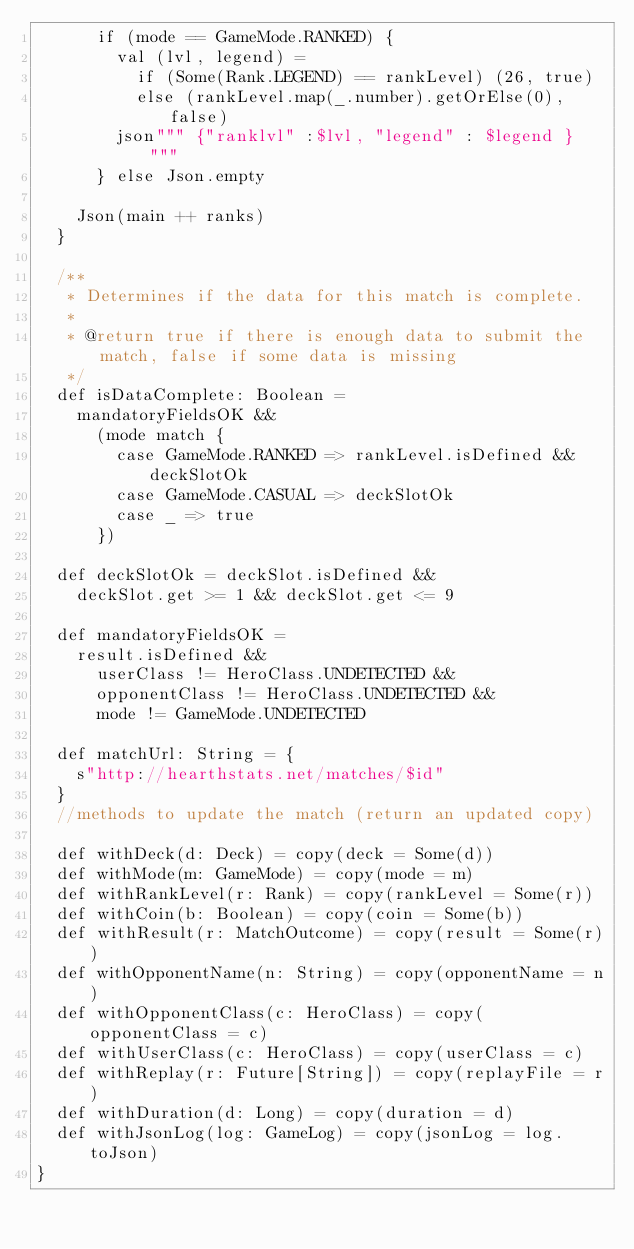<code> <loc_0><loc_0><loc_500><loc_500><_Scala_>      if (mode == GameMode.RANKED) {
        val (lvl, legend) =
          if (Some(Rank.LEGEND) == rankLevel) (26, true)
          else (rankLevel.map(_.number).getOrElse(0), false)
        json""" {"ranklvl" :$lvl, "legend" : $legend } """
      } else Json.empty

    Json(main ++ ranks)
  }

  /**
   * Determines if the data for this match is complete.
   *
   * @return true if there is enough data to submit the match, false if some data is missing
   */
  def isDataComplete: Boolean =
    mandatoryFieldsOK &&
      (mode match {
        case GameMode.RANKED => rankLevel.isDefined && deckSlotOk
        case GameMode.CASUAL => deckSlotOk
        case _ => true
      })

  def deckSlotOk = deckSlot.isDefined &&
    deckSlot.get >= 1 && deckSlot.get <= 9

  def mandatoryFieldsOK =
    result.isDefined &&
      userClass != HeroClass.UNDETECTED &&
      opponentClass != HeroClass.UNDETECTED &&
      mode != GameMode.UNDETECTED

  def matchUrl: String = {
    s"http://hearthstats.net/matches/$id"
  }
  //methods to update the match (return an updated copy)

  def withDeck(d: Deck) = copy(deck = Some(d))
  def withMode(m: GameMode) = copy(mode = m)
  def withRankLevel(r: Rank) = copy(rankLevel = Some(r))
  def withCoin(b: Boolean) = copy(coin = Some(b))
  def withResult(r: MatchOutcome) = copy(result = Some(r))
  def withOpponentName(n: String) = copy(opponentName = n)
  def withOpponentClass(c: HeroClass) = copy(opponentClass = c)
  def withUserClass(c: HeroClass) = copy(userClass = c)
  def withReplay(r: Future[String]) = copy(replayFile = r)
  def withDuration(d: Long) = copy(duration = d)
  def withJsonLog(log: GameLog) = copy(jsonLog = log.toJson)
}
</code> 